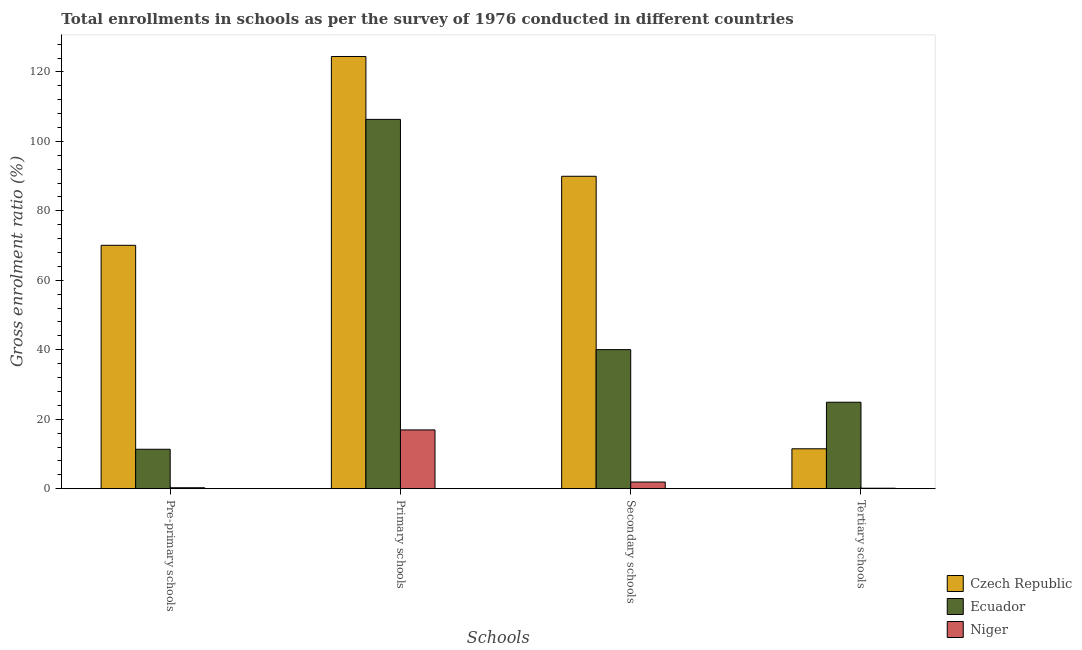How many different coloured bars are there?
Your answer should be compact. 3. How many groups of bars are there?
Your answer should be compact. 4. Are the number of bars per tick equal to the number of legend labels?
Offer a very short reply. Yes. How many bars are there on the 3rd tick from the left?
Your answer should be compact. 3. How many bars are there on the 2nd tick from the right?
Offer a terse response. 3. What is the label of the 1st group of bars from the left?
Your response must be concise. Pre-primary schools. What is the gross enrolment ratio in secondary schools in Czech Republic?
Make the answer very short. 89.95. Across all countries, what is the maximum gross enrolment ratio in secondary schools?
Provide a succinct answer. 89.95. Across all countries, what is the minimum gross enrolment ratio in secondary schools?
Offer a terse response. 1.92. In which country was the gross enrolment ratio in secondary schools maximum?
Your response must be concise. Czech Republic. In which country was the gross enrolment ratio in primary schools minimum?
Your response must be concise. Niger. What is the total gross enrolment ratio in pre-primary schools in the graph?
Your response must be concise. 81.7. What is the difference between the gross enrolment ratio in secondary schools in Czech Republic and that in Niger?
Offer a terse response. 88.04. What is the difference between the gross enrolment ratio in tertiary schools in Ecuador and the gross enrolment ratio in primary schools in Niger?
Your response must be concise. 7.97. What is the average gross enrolment ratio in primary schools per country?
Keep it short and to the point. 82.57. What is the difference between the gross enrolment ratio in tertiary schools and gross enrolment ratio in pre-primary schools in Ecuador?
Make the answer very short. 13.54. In how many countries, is the gross enrolment ratio in pre-primary schools greater than 84 %?
Your answer should be compact. 0. What is the ratio of the gross enrolment ratio in pre-primary schools in Niger to that in Ecuador?
Offer a very short reply. 0.02. What is the difference between the highest and the second highest gross enrolment ratio in tertiary schools?
Offer a terse response. 13.41. What is the difference between the highest and the lowest gross enrolment ratio in pre-primary schools?
Provide a succinct answer. 69.81. In how many countries, is the gross enrolment ratio in pre-primary schools greater than the average gross enrolment ratio in pre-primary schools taken over all countries?
Your answer should be very brief. 1. Is the sum of the gross enrolment ratio in primary schools in Czech Republic and Niger greater than the maximum gross enrolment ratio in pre-primary schools across all countries?
Provide a short and direct response. Yes. What does the 3rd bar from the left in Pre-primary schools represents?
Make the answer very short. Niger. What does the 2nd bar from the right in Tertiary schools represents?
Ensure brevity in your answer.  Ecuador. Is it the case that in every country, the sum of the gross enrolment ratio in pre-primary schools and gross enrolment ratio in primary schools is greater than the gross enrolment ratio in secondary schools?
Ensure brevity in your answer.  Yes. What is the difference between two consecutive major ticks on the Y-axis?
Your answer should be very brief. 20. Does the graph contain any zero values?
Ensure brevity in your answer.  No. Does the graph contain grids?
Give a very brief answer. No. Where does the legend appear in the graph?
Your response must be concise. Bottom right. What is the title of the graph?
Your answer should be very brief. Total enrollments in schools as per the survey of 1976 conducted in different countries. What is the label or title of the X-axis?
Provide a succinct answer. Schools. What is the label or title of the Y-axis?
Your answer should be very brief. Gross enrolment ratio (%). What is the Gross enrolment ratio (%) of Czech Republic in Pre-primary schools?
Your answer should be compact. 70.08. What is the Gross enrolment ratio (%) in Ecuador in Pre-primary schools?
Make the answer very short. 11.35. What is the Gross enrolment ratio (%) of Niger in Pre-primary schools?
Keep it short and to the point. 0.27. What is the Gross enrolment ratio (%) in Czech Republic in Primary schools?
Give a very brief answer. 124.44. What is the Gross enrolment ratio (%) in Ecuador in Primary schools?
Your response must be concise. 106.33. What is the Gross enrolment ratio (%) of Niger in Primary schools?
Ensure brevity in your answer.  16.92. What is the Gross enrolment ratio (%) in Czech Republic in Secondary schools?
Offer a terse response. 89.95. What is the Gross enrolment ratio (%) of Ecuador in Secondary schools?
Ensure brevity in your answer.  40.04. What is the Gross enrolment ratio (%) in Niger in Secondary schools?
Give a very brief answer. 1.92. What is the Gross enrolment ratio (%) of Czech Republic in Tertiary schools?
Make the answer very short. 11.48. What is the Gross enrolment ratio (%) of Ecuador in Tertiary schools?
Your answer should be compact. 24.89. What is the Gross enrolment ratio (%) of Niger in Tertiary schools?
Ensure brevity in your answer.  0.13. Across all Schools, what is the maximum Gross enrolment ratio (%) in Czech Republic?
Offer a terse response. 124.44. Across all Schools, what is the maximum Gross enrolment ratio (%) in Ecuador?
Offer a terse response. 106.33. Across all Schools, what is the maximum Gross enrolment ratio (%) of Niger?
Provide a short and direct response. 16.92. Across all Schools, what is the minimum Gross enrolment ratio (%) of Czech Republic?
Provide a succinct answer. 11.48. Across all Schools, what is the minimum Gross enrolment ratio (%) in Ecuador?
Ensure brevity in your answer.  11.35. Across all Schools, what is the minimum Gross enrolment ratio (%) in Niger?
Provide a succinct answer. 0.13. What is the total Gross enrolment ratio (%) of Czech Republic in the graph?
Provide a short and direct response. 295.96. What is the total Gross enrolment ratio (%) in Ecuador in the graph?
Your response must be concise. 182.61. What is the total Gross enrolment ratio (%) of Niger in the graph?
Offer a very short reply. 19.24. What is the difference between the Gross enrolment ratio (%) in Czech Republic in Pre-primary schools and that in Primary schools?
Provide a succinct answer. -54.37. What is the difference between the Gross enrolment ratio (%) in Ecuador in Pre-primary schools and that in Primary schools?
Your answer should be very brief. -94.98. What is the difference between the Gross enrolment ratio (%) in Niger in Pre-primary schools and that in Primary schools?
Offer a very short reply. -16.65. What is the difference between the Gross enrolment ratio (%) in Czech Republic in Pre-primary schools and that in Secondary schools?
Your answer should be compact. -19.87. What is the difference between the Gross enrolment ratio (%) of Ecuador in Pre-primary schools and that in Secondary schools?
Ensure brevity in your answer.  -28.69. What is the difference between the Gross enrolment ratio (%) in Niger in Pre-primary schools and that in Secondary schools?
Offer a very short reply. -1.65. What is the difference between the Gross enrolment ratio (%) of Czech Republic in Pre-primary schools and that in Tertiary schools?
Keep it short and to the point. 58.59. What is the difference between the Gross enrolment ratio (%) in Ecuador in Pre-primary schools and that in Tertiary schools?
Provide a short and direct response. -13.54. What is the difference between the Gross enrolment ratio (%) of Niger in Pre-primary schools and that in Tertiary schools?
Offer a terse response. 0.13. What is the difference between the Gross enrolment ratio (%) in Czech Republic in Primary schools and that in Secondary schools?
Your answer should be compact. 34.49. What is the difference between the Gross enrolment ratio (%) of Ecuador in Primary schools and that in Secondary schools?
Offer a terse response. 66.29. What is the difference between the Gross enrolment ratio (%) in Niger in Primary schools and that in Secondary schools?
Provide a succinct answer. 15. What is the difference between the Gross enrolment ratio (%) of Czech Republic in Primary schools and that in Tertiary schools?
Offer a very short reply. 112.96. What is the difference between the Gross enrolment ratio (%) of Ecuador in Primary schools and that in Tertiary schools?
Offer a very short reply. 81.44. What is the difference between the Gross enrolment ratio (%) of Niger in Primary schools and that in Tertiary schools?
Give a very brief answer. 16.79. What is the difference between the Gross enrolment ratio (%) of Czech Republic in Secondary schools and that in Tertiary schools?
Provide a succinct answer. 78.47. What is the difference between the Gross enrolment ratio (%) in Ecuador in Secondary schools and that in Tertiary schools?
Your answer should be compact. 15.14. What is the difference between the Gross enrolment ratio (%) in Niger in Secondary schools and that in Tertiary schools?
Provide a short and direct response. 1.78. What is the difference between the Gross enrolment ratio (%) of Czech Republic in Pre-primary schools and the Gross enrolment ratio (%) of Ecuador in Primary schools?
Give a very brief answer. -36.25. What is the difference between the Gross enrolment ratio (%) in Czech Republic in Pre-primary schools and the Gross enrolment ratio (%) in Niger in Primary schools?
Make the answer very short. 53.16. What is the difference between the Gross enrolment ratio (%) of Ecuador in Pre-primary schools and the Gross enrolment ratio (%) of Niger in Primary schools?
Offer a very short reply. -5.57. What is the difference between the Gross enrolment ratio (%) in Czech Republic in Pre-primary schools and the Gross enrolment ratio (%) in Ecuador in Secondary schools?
Make the answer very short. 30.04. What is the difference between the Gross enrolment ratio (%) in Czech Republic in Pre-primary schools and the Gross enrolment ratio (%) in Niger in Secondary schools?
Your answer should be compact. 68.16. What is the difference between the Gross enrolment ratio (%) of Ecuador in Pre-primary schools and the Gross enrolment ratio (%) of Niger in Secondary schools?
Offer a terse response. 9.43. What is the difference between the Gross enrolment ratio (%) in Czech Republic in Pre-primary schools and the Gross enrolment ratio (%) in Ecuador in Tertiary schools?
Make the answer very short. 45.19. What is the difference between the Gross enrolment ratio (%) of Czech Republic in Pre-primary schools and the Gross enrolment ratio (%) of Niger in Tertiary schools?
Ensure brevity in your answer.  69.94. What is the difference between the Gross enrolment ratio (%) of Ecuador in Pre-primary schools and the Gross enrolment ratio (%) of Niger in Tertiary schools?
Ensure brevity in your answer.  11.22. What is the difference between the Gross enrolment ratio (%) in Czech Republic in Primary schools and the Gross enrolment ratio (%) in Ecuador in Secondary schools?
Offer a terse response. 84.41. What is the difference between the Gross enrolment ratio (%) in Czech Republic in Primary schools and the Gross enrolment ratio (%) in Niger in Secondary schools?
Provide a short and direct response. 122.53. What is the difference between the Gross enrolment ratio (%) of Ecuador in Primary schools and the Gross enrolment ratio (%) of Niger in Secondary schools?
Give a very brief answer. 104.42. What is the difference between the Gross enrolment ratio (%) in Czech Republic in Primary schools and the Gross enrolment ratio (%) in Ecuador in Tertiary schools?
Give a very brief answer. 99.55. What is the difference between the Gross enrolment ratio (%) in Czech Republic in Primary schools and the Gross enrolment ratio (%) in Niger in Tertiary schools?
Ensure brevity in your answer.  124.31. What is the difference between the Gross enrolment ratio (%) in Ecuador in Primary schools and the Gross enrolment ratio (%) in Niger in Tertiary schools?
Make the answer very short. 106.2. What is the difference between the Gross enrolment ratio (%) of Czech Republic in Secondary schools and the Gross enrolment ratio (%) of Ecuador in Tertiary schools?
Your answer should be very brief. 65.06. What is the difference between the Gross enrolment ratio (%) of Czech Republic in Secondary schools and the Gross enrolment ratio (%) of Niger in Tertiary schools?
Your answer should be compact. 89.82. What is the difference between the Gross enrolment ratio (%) in Ecuador in Secondary schools and the Gross enrolment ratio (%) in Niger in Tertiary schools?
Provide a succinct answer. 39.9. What is the average Gross enrolment ratio (%) in Czech Republic per Schools?
Provide a succinct answer. 73.99. What is the average Gross enrolment ratio (%) in Ecuador per Schools?
Offer a very short reply. 45.65. What is the average Gross enrolment ratio (%) in Niger per Schools?
Make the answer very short. 4.81. What is the difference between the Gross enrolment ratio (%) in Czech Republic and Gross enrolment ratio (%) in Ecuador in Pre-primary schools?
Offer a very short reply. 58.73. What is the difference between the Gross enrolment ratio (%) of Czech Republic and Gross enrolment ratio (%) of Niger in Pre-primary schools?
Your answer should be compact. 69.81. What is the difference between the Gross enrolment ratio (%) of Ecuador and Gross enrolment ratio (%) of Niger in Pre-primary schools?
Keep it short and to the point. 11.08. What is the difference between the Gross enrolment ratio (%) in Czech Republic and Gross enrolment ratio (%) in Ecuador in Primary schools?
Keep it short and to the point. 18.11. What is the difference between the Gross enrolment ratio (%) in Czech Republic and Gross enrolment ratio (%) in Niger in Primary schools?
Your answer should be compact. 107.52. What is the difference between the Gross enrolment ratio (%) of Ecuador and Gross enrolment ratio (%) of Niger in Primary schools?
Ensure brevity in your answer.  89.41. What is the difference between the Gross enrolment ratio (%) of Czech Republic and Gross enrolment ratio (%) of Ecuador in Secondary schools?
Offer a very short reply. 49.92. What is the difference between the Gross enrolment ratio (%) of Czech Republic and Gross enrolment ratio (%) of Niger in Secondary schools?
Keep it short and to the point. 88.04. What is the difference between the Gross enrolment ratio (%) of Ecuador and Gross enrolment ratio (%) of Niger in Secondary schools?
Make the answer very short. 38.12. What is the difference between the Gross enrolment ratio (%) in Czech Republic and Gross enrolment ratio (%) in Ecuador in Tertiary schools?
Offer a terse response. -13.41. What is the difference between the Gross enrolment ratio (%) of Czech Republic and Gross enrolment ratio (%) of Niger in Tertiary schools?
Provide a short and direct response. 11.35. What is the difference between the Gross enrolment ratio (%) of Ecuador and Gross enrolment ratio (%) of Niger in Tertiary schools?
Ensure brevity in your answer.  24.76. What is the ratio of the Gross enrolment ratio (%) of Czech Republic in Pre-primary schools to that in Primary schools?
Your answer should be very brief. 0.56. What is the ratio of the Gross enrolment ratio (%) of Ecuador in Pre-primary schools to that in Primary schools?
Provide a short and direct response. 0.11. What is the ratio of the Gross enrolment ratio (%) in Niger in Pre-primary schools to that in Primary schools?
Your response must be concise. 0.02. What is the ratio of the Gross enrolment ratio (%) of Czech Republic in Pre-primary schools to that in Secondary schools?
Keep it short and to the point. 0.78. What is the ratio of the Gross enrolment ratio (%) of Ecuador in Pre-primary schools to that in Secondary schools?
Offer a very short reply. 0.28. What is the ratio of the Gross enrolment ratio (%) in Niger in Pre-primary schools to that in Secondary schools?
Ensure brevity in your answer.  0.14. What is the ratio of the Gross enrolment ratio (%) in Czech Republic in Pre-primary schools to that in Tertiary schools?
Ensure brevity in your answer.  6.1. What is the ratio of the Gross enrolment ratio (%) of Ecuador in Pre-primary schools to that in Tertiary schools?
Keep it short and to the point. 0.46. What is the ratio of the Gross enrolment ratio (%) in Niger in Pre-primary schools to that in Tertiary schools?
Provide a short and direct response. 1.98. What is the ratio of the Gross enrolment ratio (%) of Czech Republic in Primary schools to that in Secondary schools?
Provide a short and direct response. 1.38. What is the ratio of the Gross enrolment ratio (%) of Ecuador in Primary schools to that in Secondary schools?
Make the answer very short. 2.66. What is the ratio of the Gross enrolment ratio (%) of Niger in Primary schools to that in Secondary schools?
Provide a succinct answer. 8.83. What is the ratio of the Gross enrolment ratio (%) in Czech Republic in Primary schools to that in Tertiary schools?
Your answer should be compact. 10.84. What is the ratio of the Gross enrolment ratio (%) of Ecuador in Primary schools to that in Tertiary schools?
Offer a terse response. 4.27. What is the ratio of the Gross enrolment ratio (%) of Niger in Primary schools to that in Tertiary schools?
Offer a terse response. 125.69. What is the ratio of the Gross enrolment ratio (%) of Czech Republic in Secondary schools to that in Tertiary schools?
Make the answer very short. 7.83. What is the ratio of the Gross enrolment ratio (%) of Ecuador in Secondary schools to that in Tertiary schools?
Provide a short and direct response. 1.61. What is the ratio of the Gross enrolment ratio (%) in Niger in Secondary schools to that in Tertiary schools?
Ensure brevity in your answer.  14.24. What is the difference between the highest and the second highest Gross enrolment ratio (%) in Czech Republic?
Give a very brief answer. 34.49. What is the difference between the highest and the second highest Gross enrolment ratio (%) of Ecuador?
Your answer should be very brief. 66.29. What is the difference between the highest and the second highest Gross enrolment ratio (%) in Niger?
Your answer should be very brief. 15. What is the difference between the highest and the lowest Gross enrolment ratio (%) of Czech Republic?
Your answer should be compact. 112.96. What is the difference between the highest and the lowest Gross enrolment ratio (%) of Ecuador?
Offer a terse response. 94.98. What is the difference between the highest and the lowest Gross enrolment ratio (%) of Niger?
Give a very brief answer. 16.79. 